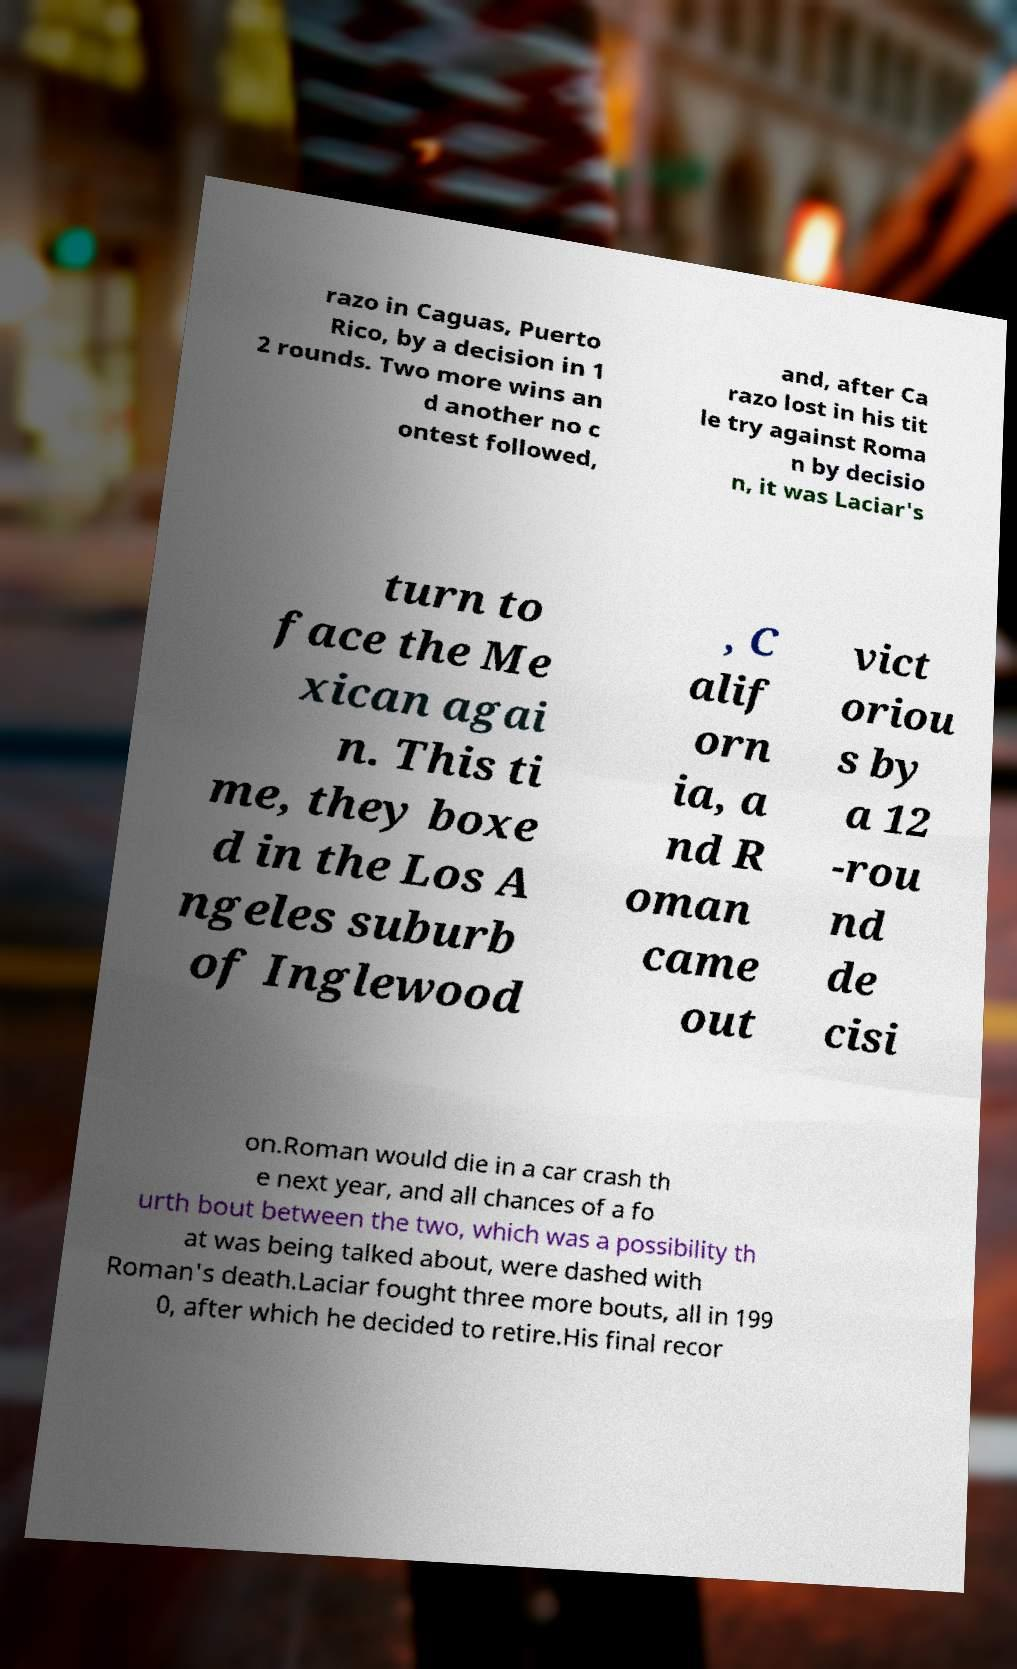Can you read and provide the text displayed in the image?This photo seems to have some interesting text. Can you extract and type it out for me? razo in Caguas, Puerto Rico, by a decision in 1 2 rounds. Two more wins an d another no c ontest followed, and, after Ca razo lost in his tit le try against Roma n by decisio n, it was Laciar's turn to face the Me xican agai n. This ti me, they boxe d in the Los A ngeles suburb of Inglewood , C alif orn ia, a nd R oman came out vict oriou s by a 12 -rou nd de cisi on.Roman would die in a car crash th e next year, and all chances of a fo urth bout between the two, which was a possibility th at was being talked about, were dashed with Roman's death.Laciar fought three more bouts, all in 199 0, after which he decided to retire.His final recor 